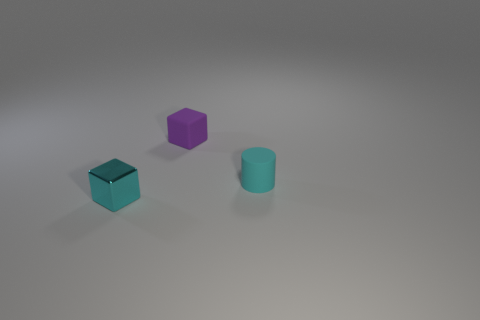Is there anything else that has the same material as the cyan block?
Your answer should be very brief. No. Do the metal thing and the object that is to the right of the purple matte thing have the same color?
Provide a succinct answer. Yes. Is there any other thing of the same color as the shiny thing?
Your answer should be compact. Yes. There is a cyan object right of the cyan cube; is it the same shape as the tiny purple object?
Provide a short and direct response. No. What is the shape of the small cyan object that is behind the small cube that is left of the block that is behind the cyan block?
Offer a terse response. Cylinder. What is the shape of the thing that is the same color as the metal cube?
Offer a terse response. Cylinder. There is a tiny object that is both to the left of the matte cylinder and on the right side of the small cyan shiny thing; what is its material?
Keep it short and to the point. Rubber. Is the number of small purple cubes less than the number of tiny purple cylinders?
Provide a succinct answer. No. Is the shape of the cyan metal thing the same as the rubber object that is behind the small cylinder?
Ensure brevity in your answer.  Yes. Does the object that is to the right of the purple matte thing have the same size as the rubber block?
Give a very brief answer. Yes. 